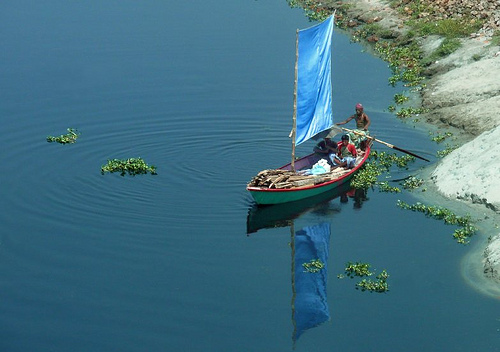<image>
Can you confirm if the boat is in the water? Yes. The boat is contained within or inside the water, showing a containment relationship. 